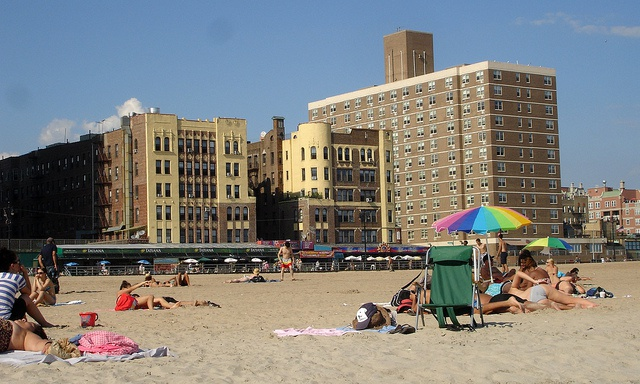Describe the objects in this image and their specific colors. I can see people in gray, black, and tan tones, chair in gray, teal, black, and darkgreen tones, people in gray, black, maroon, and darkgray tones, umbrella in gray, lightgreen, blue, lightblue, and violet tones, and people in gray, tan, and darkgray tones in this image. 